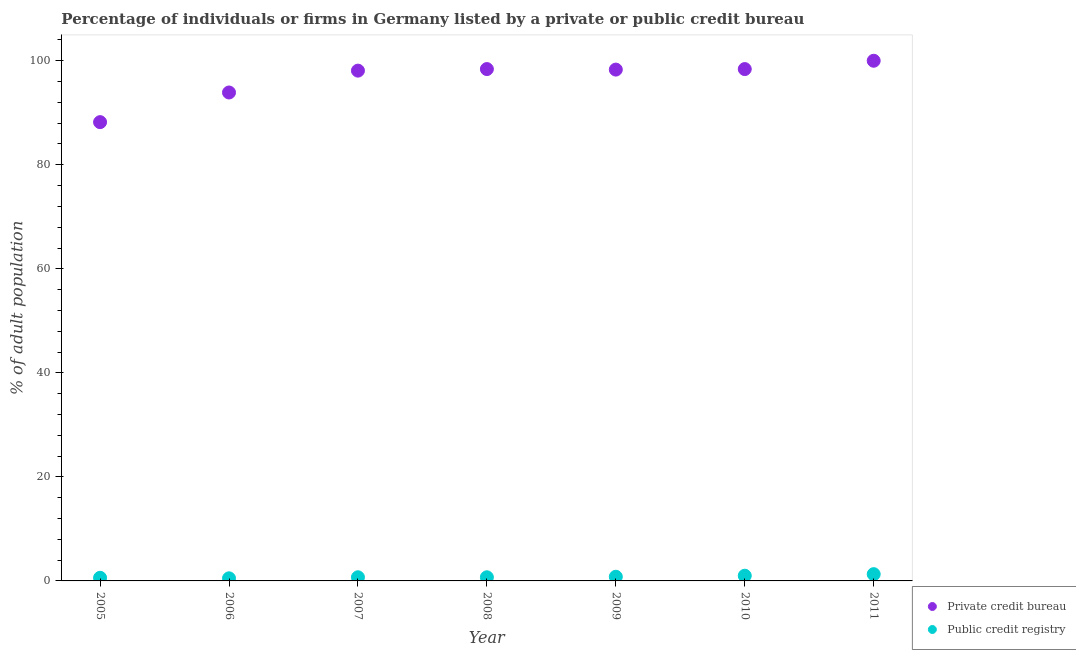How many different coloured dotlines are there?
Provide a succinct answer. 2. Is the number of dotlines equal to the number of legend labels?
Keep it short and to the point. Yes. What is the percentage of firms listed by public credit bureau in 2005?
Offer a very short reply. 0.6. Across all years, what is the minimum percentage of firms listed by public credit bureau?
Your answer should be compact. 0.5. What is the total percentage of firms listed by private credit bureau in the graph?
Provide a succinct answer. 675.3. What is the difference between the percentage of firms listed by public credit bureau in 2007 and that in 2010?
Keep it short and to the point. -0.3. What is the difference between the percentage of firms listed by private credit bureau in 2008 and the percentage of firms listed by public credit bureau in 2005?
Offer a very short reply. 97.8. What is the average percentage of firms listed by public credit bureau per year?
Your answer should be very brief. 0.8. In the year 2005, what is the difference between the percentage of firms listed by public credit bureau and percentage of firms listed by private credit bureau?
Your answer should be compact. -87.6. In how many years, is the percentage of firms listed by private credit bureau greater than 80 %?
Your answer should be compact. 7. What is the ratio of the percentage of firms listed by public credit bureau in 2010 to that in 2011?
Your response must be concise. 0.77. Is the difference between the percentage of firms listed by public credit bureau in 2008 and 2011 greater than the difference between the percentage of firms listed by private credit bureau in 2008 and 2011?
Offer a terse response. Yes. What is the difference between the highest and the second highest percentage of firms listed by private credit bureau?
Make the answer very short. 1.6. What is the difference between the highest and the lowest percentage of firms listed by private credit bureau?
Give a very brief answer. 11.8. In how many years, is the percentage of firms listed by private credit bureau greater than the average percentage of firms listed by private credit bureau taken over all years?
Your answer should be very brief. 5. Is the sum of the percentage of firms listed by public credit bureau in 2005 and 2011 greater than the maximum percentage of firms listed by private credit bureau across all years?
Offer a terse response. No. Is the percentage of firms listed by private credit bureau strictly greater than the percentage of firms listed by public credit bureau over the years?
Give a very brief answer. Yes. How many dotlines are there?
Your answer should be compact. 2. How many years are there in the graph?
Provide a short and direct response. 7. Are the values on the major ticks of Y-axis written in scientific E-notation?
Make the answer very short. No. Does the graph contain any zero values?
Keep it short and to the point. No. How are the legend labels stacked?
Your answer should be very brief. Vertical. What is the title of the graph?
Make the answer very short. Percentage of individuals or firms in Germany listed by a private or public credit bureau. What is the label or title of the X-axis?
Your response must be concise. Year. What is the label or title of the Y-axis?
Keep it short and to the point. % of adult population. What is the % of adult population in Private credit bureau in 2005?
Keep it short and to the point. 88.2. What is the % of adult population in Public credit registry in 2005?
Keep it short and to the point. 0.6. What is the % of adult population of Private credit bureau in 2006?
Your answer should be very brief. 93.9. What is the % of adult population in Private credit bureau in 2007?
Make the answer very short. 98.1. What is the % of adult population of Private credit bureau in 2008?
Offer a terse response. 98.4. What is the % of adult population in Private credit bureau in 2009?
Give a very brief answer. 98.3. What is the % of adult population in Private credit bureau in 2010?
Your answer should be very brief. 98.4. What is the % of adult population of Public credit registry in 2010?
Keep it short and to the point. 1. Across all years, what is the maximum % of adult population in Private credit bureau?
Offer a very short reply. 100. Across all years, what is the minimum % of adult population of Private credit bureau?
Provide a short and direct response. 88.2. Across all years, what is the minimum % of adult population in Public credit registry?
Your response must be concise. 0.5. What is the total % of adult population in Private credit bureau in the graph?
Offer a terse response. 675.3. What is the difference between the % of adult population of Private credit bureau in 2005 and that in 2007?
Offer a terse response. -9.9. What is the difference between the % of adult population in Public credit registry in 2005 and that in 2007?
Your answer should be very brief. -0.1. What is the difference between the % of adult population in Private credit bureau in 2005 and that in 2008?
Provide a short and direct response. -10.2. What is the difference between the % of adult population in Private credit bureau in 2005 and that in 2009?
Your response must be concise. -10.1. What is the difference between the % of adult population of Public credit registry in 2005 and that in 2009?
Your response must be concise. -0.2. What is the difference between the % of adult population of Private credit bureau in 2005 and that in 2010?
Give a very brief answer. -10.2. What is the difference between the % of adult population of Public credit registry in 2005 and that in 2010?
Your response must be concise. -0.4. What is the difference between the % of adult population in Private credit bureau in 2005 and that in 2011?
Provide a succinct answer. -11.8. What is the difference between the % of adult population of Private credit bureau in 2006 and that in 2007?
Give a very brief answer. -4.2. What is the difference between the % of adult population in Private credit bureau in 2006 and that in 2009?
Make the answer very short. -4.4. What is the difference between the % of adult population of Public credit registry in 2006 and that in 2009?
Provide a succinct answer. -0.3. What is the difference between the % of adult population of Private credit bureau in 2007 and that in 2010?
Provide a succinct answer. -0.3. What is the difference between the % of adult population in Public credit registry in 2007 and that in 2011?
Your answer should be very brief. -0.6. What is the difference between the % of adult population of Private credit bureau in 2008 and that in 2009?
Provide a short and direct response. 0.1. What is the difference between the % of adult population of Public credit registry in 2008 and that in 2010?
Provide a succinct answer. -0.3. What is the difference between the % of adult population in Private credit bureau in 2008 and that in 2011?
Offer a very short reply. -1.6. What is the difference between the % of adult population of Private credit bureau in 2009 and that in 2011?
Keep it short and to the point. -1.7. What is the difference between the % of adult population of Private credit bureau in 2005 and the % of adult population of Public credit registry in 2006?
Provide a succinct answer. 87.7. What is the difference between the % of adult population of Private credit bureau in 2005 and the % of adult population of Public credit registry in 2007?
Keep it short and to the point. 87.5. What is the difference between the % of adult population of Private credit bureau in 2005 and the % of adult population of Public credit registry in 2008?
Your response must be concise. 87.5. What is the difference between the % of adult population of Private credit bureau in 2005 and the % of adult population of Public credit registry in 2009?
Your response must be concise. 87.4. What is the difference between the % of adult population of Private credit bureau in 2005 and the % of adult population of Public credit registry in 2010?
Give a very brief answer. 87.2. What is the difference between the % of adult population of Private credit bureau in 2005 and the % of adult population of Public credit registry in 2011?
Your response must be concise. 86.9. What is the difference between the % of adult population in Private credit bureau in 2006 and the % of adult population in Public credit registry in 2007?
Offer a terse response. 93.2. What is the difference between the % of adult population of Private credit bureau in 2006 and the % of adult population of Public credit registry in 2008?
Keep it short and to the point. 93.2. What is the difference between the % of adult population in Private credit bureau in 2006 and the % of adult population in Public credit registry in 2009?
Make the answer very short. 93.1. What is the difference between the % of adult population in Private credit bureau in 2006 and the % of adult population in Public credit registry in 2010?
Provide a short and direct response. 92.9. What is the difference between the % of adult population of Private credit bureau in 2006 and the % of adult population of Public credit registry in 2011?
Provide a succinct answer. 92.6. What is the difference between the % of adult population of Private credit bureau in 2007 and the % of adult population of Public credit registry in 2008?
Give a very brief answer. 97.4. What is the difference between the % of adult population in Private credit bureau in 2007 and the % of adult population in Public credit registry in 2009?
Your response must be concise. 97.3. What is the difference between the % of adult population of Private credit bureau in 2007 and the % of adult population of Public credit registry in 2010?
Provide a succinct answer. 97.1. What is the difference between the % of adult population in Private credit bureau in 2007 and the % of adult population in Public credit registry in 2011?
Offer a very short reply. 96.8. What is the difference between the % of adult population of Private credit bureau in 2008 and the % of adult population of Public credit registry in 2009?
Offer a terse response. 97.6. What is the difference between the % of adult population in Private credit bureau in 2008 and the % of adult population in Public credit registry in 2010?
Make the answer very short. 97.4. What is the difference between the % of adult population of Private credit bureau in 2008 and the % of adult population of Public credit registry in 2011?
Your answer should be compact. 97.1. What is the difference between the % of adult population in Private credit bureau in 2009 and the % of adult population in Public credit registry in 2010?
Your answer should be very brief. 97.3. What is the difference between the % of adult population in Private credit bureau in 2009 and the % of adult population in Public credit registry in 2011?
Ensure brevity in your answer.  97. What is the difference between the % of adult population in Private credit bureau in 2010 and the % of adult population in Public credit registry in 2011?
Provide a short and direct response. 97.1. What is the average % of adult population in Private credit bureau per year?
Ensure brevity in your answer.  96.47. In the year 2005, what is the difference between the % of adult population in Private credit bureau and % of adult population in Public credit registry?
Offer a terse response. 87.6. In the year 2006, what is the difference between the % of adult population in Private credit bureau and % of adult population in Public credit registry?
Offer a very short reply. 93.4. In the year 2007, what is the difference between the % of adult population of Private credit bureau and % of adult population of Public credit registry?
Your answer should be compact. 97.4. In the year 2008, what is the difference between the % of adult population of Private credit bureau and % of adult population of Public credit registry?
Your response must be concise. 97.7. In the year 2009, what is the difference between the % of adult population in Private credit bureau and % of adult population in Public credit registry?
Your response must be concise. 97.5. In the year 2010, what is the difference between the % of adult population of Private credit bureau and % of adult population of Public credit registry?
Make the answer very short. 97.4. In the year 2011, what is the difference between the % of adult population in Private credit bureau and % of adult population in Public credit registry?
Offer a very short reply. 98.7. What is the ratio of the % of adult population in Private credit bureau in 2005 to that in 2006?
Ensure brevity in your answer.  0.94. What is the ratio of the % of adult population of Public credit registry in 2005 to that in 2006?
Keep it short and to the point. 1.2. What is the ratio of the % of adult population in Private credit bureau in 2005 to that in 2007?
Give a very brief answer. 0.9. What is the ratio of the % of adult population of Public credit registry in 2005 to that in 2007?
Your response must be concise. 0.86. What is the ratio of the % of adult population in Private credit bureau in 2005 to that in 2008?
Ensure brevity in your answer.  0.9. What is the ratio of the % of adult population of Private credit bureau in 2005 to that in 2009?
Your answer should be very brief. 0.9. What is the ratio of the % of adult population in Private credit bureau in 2005 to that in 2010?
Provide a succinct answer. 0.9. What is the ratio of the % of adult population in Public credit registry in 2005 to that in 2010?
Make the answer very short. 0.6. What is the ratio of the % of adult population in Private credit bureau in 2005 to that in 2011?
Your response must be concise. 0.88. What is the ratio of the % of adult population of Public credit registry in 2005 to that in 2011?
Provide a short and direct response. 0.46. What is the ratio of the % of adult population in Private credit bureau in 2006 to that in 2007?
Your response must be concise. 0.96. What is the ratio of the % of adult population of Public credit registry in 2006 to that in 2007?
Give a very brief answer. 0.71. What is the ratio of the % of adult population in Private credit bureau in 2006 to that in 2008?
Your answer should be very brief. 0.95. What is the ratio of the % of adult population in Private credit bureau in 2006 to that in 2009?
Provide a succinct answer. 0.96. What is the ratio of the % of adult population in Private credit bureau in 2006 to that in 2010?
Provide a succinct answer. 0.95. What is the ratio of the % of adult population of Public credit registry in 2006 to that in 2010?
Offer a very short reply. 0.5. What is the ratio of the % of adult population in Private credit bureau in 2006 to that in 2011?
Provide a succinct answer. 0.94. What is the ratio of the % of adult population in Public credit registry in 2006 to that in 2011?
Your answer should be compact. 0.38. What is the ratio of the % of adult population of Public credit registry in 2007 to that in 2008?
Offer a terse response. 1. What is the ratio of the % of adult population of Private credit bureau in 2007 to that in 2009?
Your response must be concise. 1. What is the ratio of the % of adult population of Private credit bureau in 2007 to that in 2010?
Offer a very short reply. 1. What is the ratio of the % of adult population of Public credit registry in 2007 to that in 2010?
Your answer should be compact. 0.7. What is the ratio of the % of adult population in Public credit registry in 2007 to that in 2011?
Offer a terse response. 0.54. What is the ratio of the % of adult population in Private credit bureau in 2008 to that in 2009?
Your response must be concise. 1. What is the ratio of the % of adult population of Public credit registry in 2008 to that in 2011?
Provide a succinct answer. 0.54. What is the ratio of the % of adult population in Private credit bureau in 2009 to that in 2010?
Give a very brief answer. 1. What is the ratio of the % of adult population of Private credit bureau in 2009 to that in 2011?
Offer a very short reply. 0.98. What is the ratio of the % of adult population of Public credit registry in 2009 to that in 2011?
Offer a terse response. 0.62. What is the ratio of the % of adult population in Public credit registry in 2010 to that in 2011?
Give a very brief answer. 0.77. What is the difference between the highest and the second highest % of adult population in Private credit bureau?
Provide a succinct answer. 1.6. 